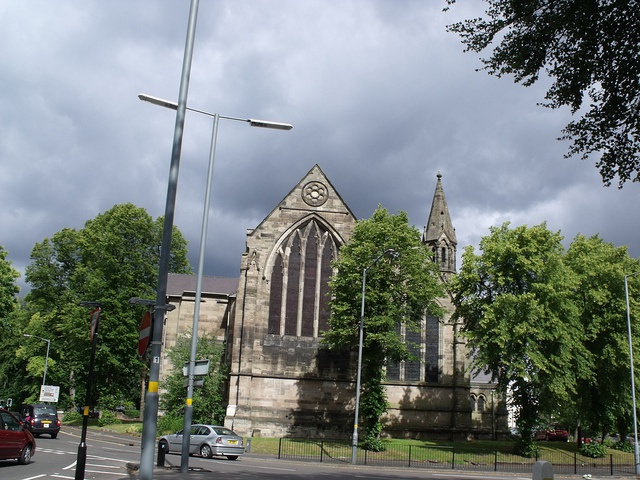Describe the objects in this image and their specific colors. I can see car in lavender, gray, darkgray, black, and lightgray tones, car in lavender, black, maroon, gray, and purple tones, car in lavender, black, gray, and purple tones, and car in lavender, black, maroon, gray, and darkgreen tones in this image. 